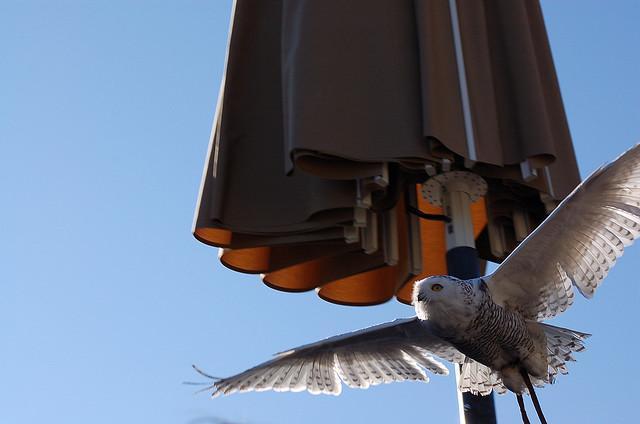Verify the accuracy of this image caption: "The umbrella is under the bird.".
Answer yes or no. No. Does the caption "The bird is below the umbrella." correctly depict the image?
Answer yes or no. Yes. 